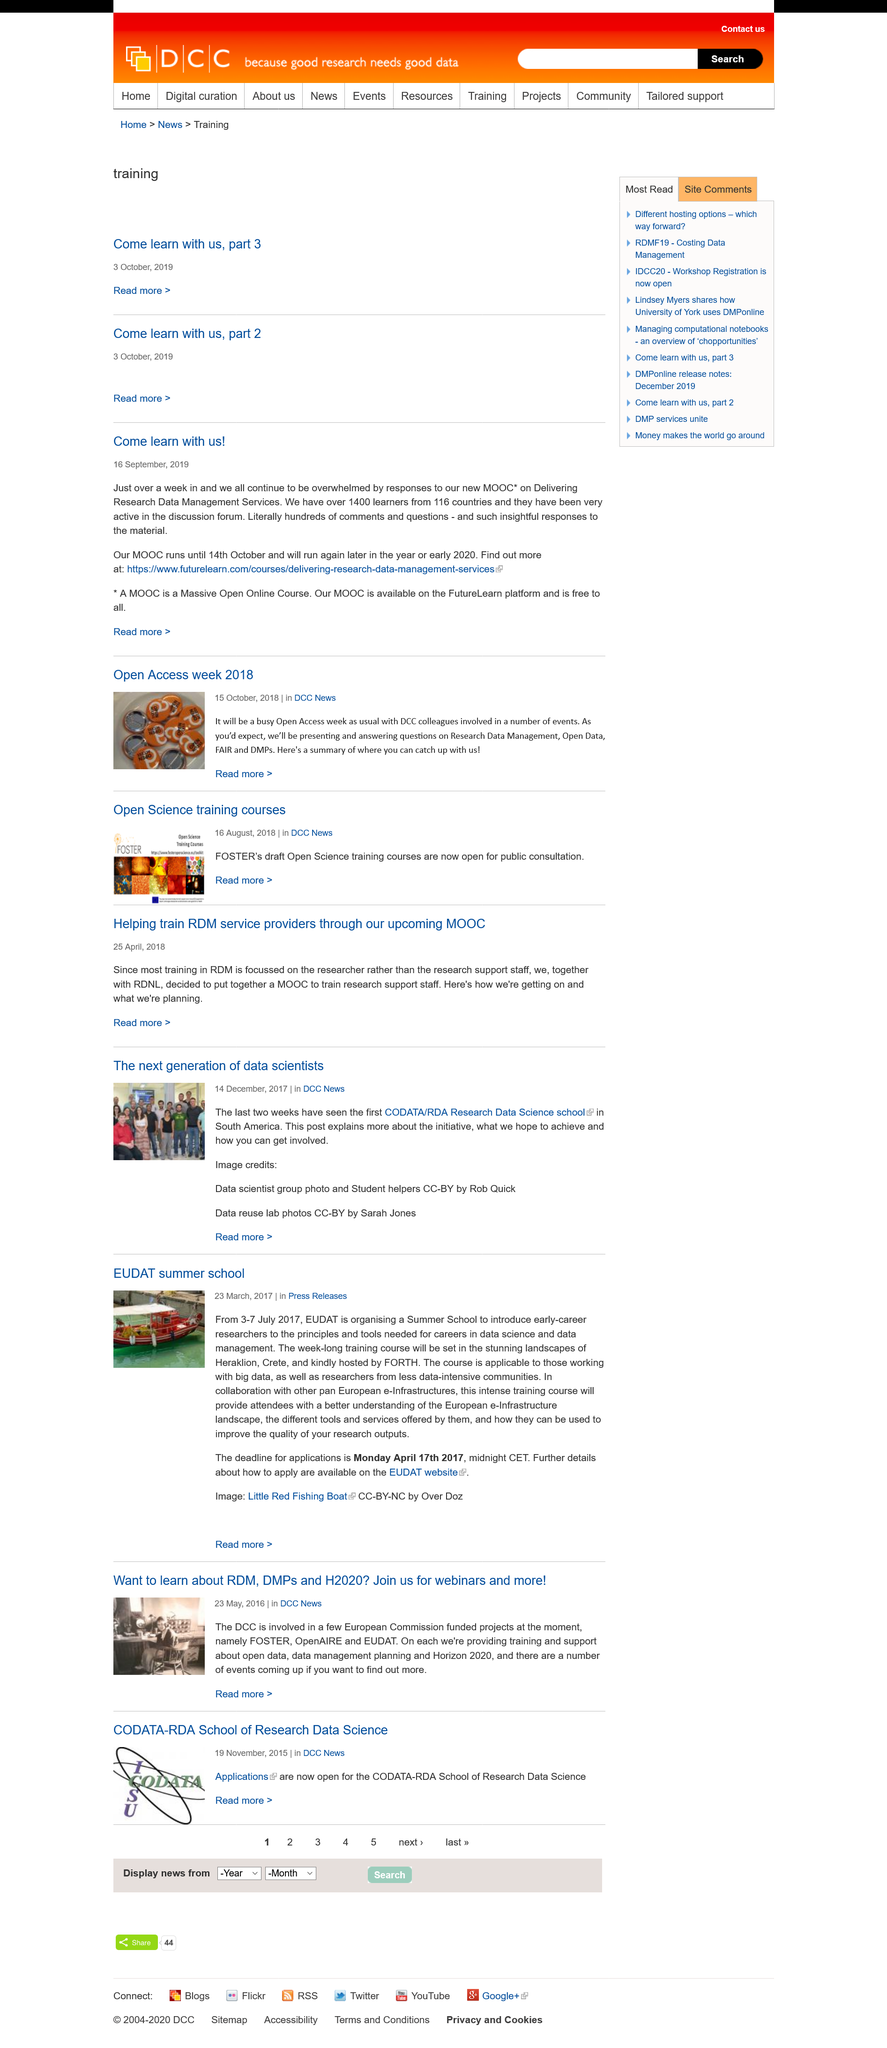Draw attention to some important aspects in this diagram. The article on the EUDAT summer school was published on March 23, 2017. The Summer School training course will take place in the breathtaking surroundings of Heraklion, Crete. The Summer School organized by EUDAT is being held from 3-7 July 2017. 